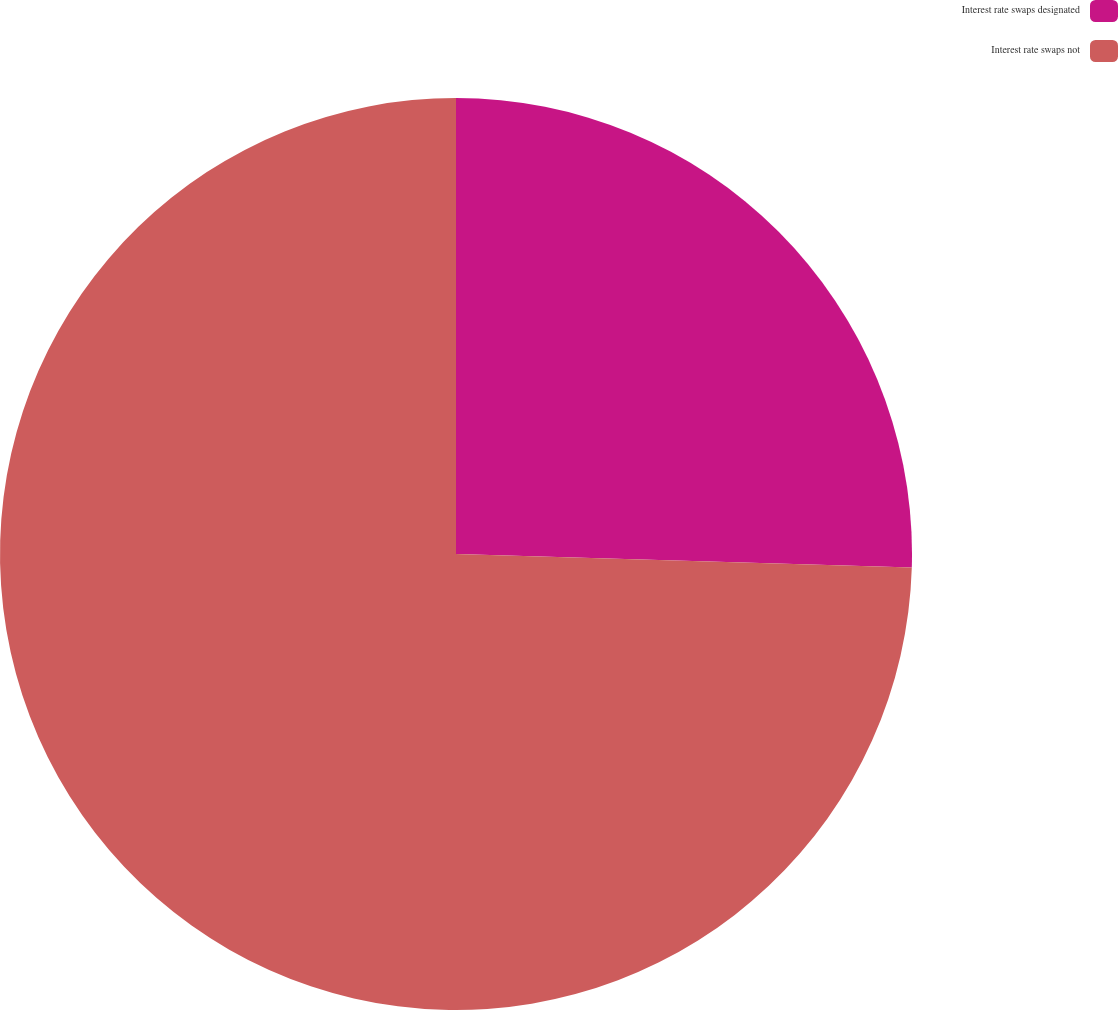Convert chart to OTSL. <chart><loc_0><loc_0><loc_500><loc_500><pie_chart><fcel>Interest rate swaps designated<fcel>Interest rate swaps not<nl><fcel>25.47%<fcel>74.53%<nl></chart> 